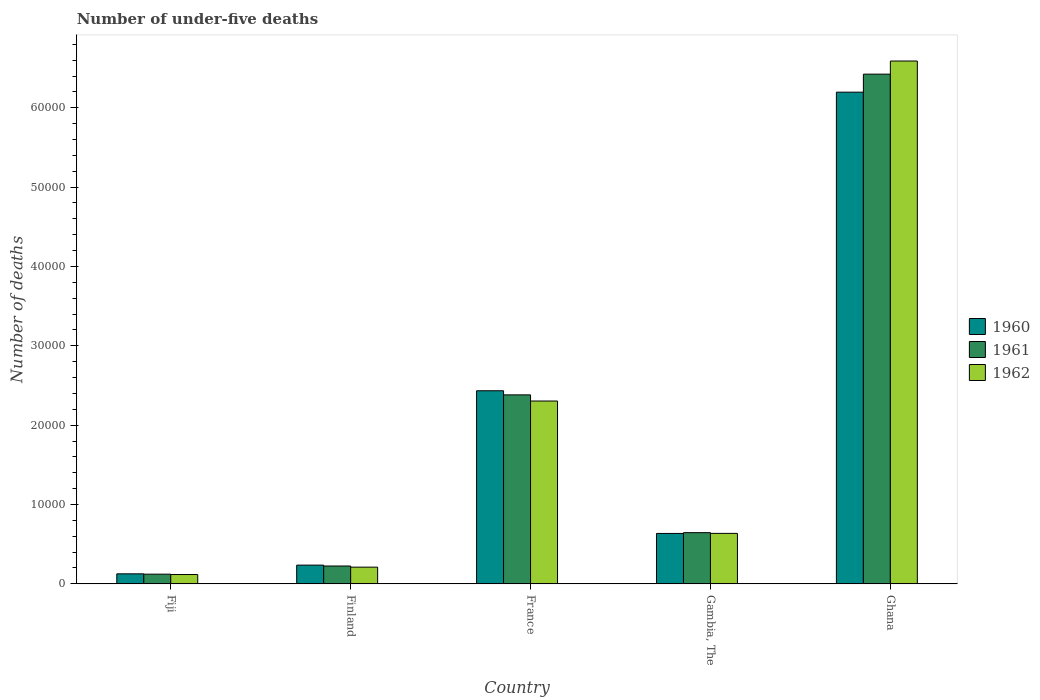How many different coloured bars are there?
Provide a short and direct response. 3. How many bars are there on the 5th tick from the right?
Offer a terse response. 3. In how many cases, is the number of bars for a given country not equal to the number of legend labels?
Offer a very short reply. 0. What is the number of under-five deaths in 1962 in Finland?
Your answer should be very brief. 2106. Across all countries, what is the maximum number of under-five deaths in 1961?
Make the answer very short. 6.42e+04. Across all countries, what is the minimum number of under-five deaths in 1962?
Give a very brief answer. 1176. In which country was the number of under-five deaths in 1961 minimum?
Make the answer very short. Fiji. What is the total number of under-five deaths in 1960 in the graph?
Provide a short and direct response. 9.63e+04. What is the difference between the number of under-five deaths in 1960 in Finland and that in Gambia, The?
Keep it short and to the point. -3990. What is the difference between the number of under-five deaths in 1960 in Gambia, The and the number of under-five deaths in 1961 in Fiji?
Your answer should be very brief. 5131. What is the average number of under-five deaths in 1960 per country?
Make the answer very short. 1.93e+04. What is the difference between the number of under-five deaths of/in 1961 and number of under-five deaths of/in 1960 in France?
Your answer should be compact. -517. In how many countries, is the number of under-five deaths in 1961 greater than 58000?
Make the answer very short. 1. What is the ratio of the number of under-five deaths in 1960 in Finland to that in Ghana?
Offer a terse response. 0.04. Is the difference between the number of under-five deaths in 1961 in Fiji and France greater than the difference between the number of under-five deaths in 1960 in Fiji and France?
Provide a succinct answer. Yes. What is the difference between the highest and the second highest number of under-five deaths in 1961?
Ensure brevity in your answer.  1.74e+04. What is the difference between the highest and the lowest number of under-five deaths in 1960?
Offer a terse response. 6.07e+04. In how many countries, is the number of under-five deaths in 1961 greater than the average number of under-five deaths in 1961 taken over all countries?
Offer a terse response. 2. Is the sum of the number of under-five deaths in 1960 in Gambia, The and Ghana greater than the maximum number of under-five deaths in 1961 across all countries?
Give a very brief answer. Yes. What does the 3rd bar from the left in Finland represents?
Give a very brief answer. 1962. What does the 1st bar from the right in Gambia, The represents?
Offer a very short reply. 1962. How many bars are there?
Give a very brief answer. 15. How many countries are there in the graph?
Give a very brief answer. 5. What is the difference between two consecutive major ticks on the Y-axis?
Ensure brevity in your answer.  10000. Does the graph contain any zero values?
Your response must be concise. No. Does the graph contain grids?
Offer a terse response. No. What is the title of the graph?
Offer a very short reply. Number of under-five deaths. Does "1988" appear as one of the legend labels in the graph?
Provide a succinct answer. No. What is the label or title of the Y-axis?
Offer a very short reply. Number of deaths. What is the Number of deaths of 1960 in Fiji?
Your answer should be very brief. 1263. What is the Number of deaths in 1961 in Fiji?
Give a very brief answer. 1222. What is the Number of deaths in 1962 in Fiji?
Provide a short and direct response. 1176. What is the Number of deaths in 1960 in Finland?
Your answer should be very brief. 2363. What is the Number of deaths in 1961 in Finland?
Keep it short and to the point. 2251. What is the Number of deaths in 1962 in Finland?
Your answer should be compact. 2106. What is the Number of deaths in 1960 in France?
Provide a short and direct response. 2.43e+04. What is the Number of deaths in 1961 in France?
Make the answer very short. 2.38e+04. What is the Number of deaths of 1962 in France?
Your answer should be very brief. 2.30e+04. What is the Number of deaths of 1960 in Gambia, The?
Ensure brevity in your answer.  6353. What is the Number of deaths in 1961 in Gambia, The?
Provide a short and direct response. 6452. What is the Number of deaths of 1962 in Gambia, The?
Your answer should be compact. 6361. What is the Number of deaths in 1960 in Ghana?
Offer a terse response. 6.20e+04. What is the Number of deaths in 1961 in Ghana?
Make the answer very short. 6.42e+04. What is the Number of deaths in 1962 in Ghana?
Your answer should be very brief. 6.59e+04. Across all countries, what is the maximum Number of deaths in 1960?
Ensure brevity in your answer.  6.20e+04. Across all countries, what is the maximum Number of deaths of 1961?
Offer a terse response. 6.42e+04. Across all countries, what is the maximum Number of deaths in 1962?
Offer a terse response. 6.59e+04. Across all countries, what is the minimum Number of deaths in 1960?
Give a very brief answer. 1263. Across all countries, what is the minimum Number of deaths of 1961?
Offer a terse response. 1222. Across all countries, what is the minimum Number of deaths in 1962?
Ensure brevity in your answer.  1176. What is the total Number of deaths in 1960 in the graph?
Offer a terse response. 9.63e+04. What is the total Number of deaths in 1961 in the graph?
Keep it short and to the point. 9.80e+04. What is the total Number of deaths in 1962 in the graph?
Offer a very short reply. 9.86e+04. What is the difference between the Number of deaths in 1960 in Fiji and that in Finland?
Offer a terse response. -1100. What is the difference between the Number of deaths in 1961 in Fiji and that in Finland?
Offer a terse response. -1029. What is the difference between the Number of deaths of 1962 in Fiji and that in Finland?
Your answer should be compact. -930. What is the difference between the Number of deaths of 1960 in Fiji and that in France?
Your answer should be compact. -2.31e+04. What is the difference between the Number of deaths of 1961 in Fiji and that in France?
Your response must be concise. -2.26e+04. What is the difference between the Number of deaths of 1962 in Fiji and that in France?
Give a very brief answer. -2.19e+04. What is the difference between the Number of deaths of 1960 in Fiji and that in Gambia, The?
Offer a terse response. -5090. What is the difference between the Number of deaths in 1961 in Fiji and that in Gambia, The?
Your answer should be compact. -5230. What is the difference between the Number of deaths of 1962 in Fiji and that in Gambia, The?
Ensure brevity in your answer.  -5185. What is the difference between the Number of deaths of 1960 in Fiji and that in Ghana?
Provide a short and direct response. -6.07e+04. What is the difference between the Number of deaths in 1961 in Fiji and that in Ghana?
Make the answer very short. -6.30e+04. What is the difference between the Number of deaths of 1962 in Fiji and that in Ghana?
Provide a succinct answer. -6.47e+04. What is the difference between the Number of deaths of 1960 in Finland and that in France?
Ensure brevity in your answer.  -2.20e+04. What is the difference between the Number of deaths in 1961 in Finland and that in France?
Ensure brevity in your answer.  -2.16e+04. What is the difference between the Number of deaths in 1962 in Finland and that in France?
Keep it short and to the point. -2.09e+04. What is the difference between the Number of deaths in 1960 in Finland and that in Gambia, The?
Offer a terse response. -3990. What is the difference between the Number of deaths of 1961 in Finland and that in Gambia, The?
Provide a short and direct response. -4201. What is the difference between the Number of deaths in 1962 in Finland and that in Gambia, The?
Ensure brevity in your answer.  -4255. What is the difference between the Number of deaths of 1960 in Finland and that in Ghana?
Ensure brevity in your answer.  -5.96e+04. What is the difference between the Number of deaths in 1961 in Finland and that in Ghana?
Offer a very short reply. -6.20e+04. What is the difference between the Number of deaths of 1962 in Finland and that in Ghana?
Your answer should be compact. -6.38e+04. What is the difference between the Number of deaths of 1960 in France and that in Gambia, The?
Offer a terse response. 1.80e+04. What is the difference between the Number of deaths of 1961 in France and that in Gambia, The?
Offer a very short reply. 1.74e+04. What is the difference between the Number of deaths of 1962 in France and that in Gambia, The?
Your answer should be compact. 1.67e+04. What is the difference between the Number of deaths of 1960 in France and that in Ghana?
Ensure brevity in your answer.  -3.76e+04. What is the difference between the Number of deaths of 1961 in France and that in Ghana?
Offer a terse response. -4.04e+04. What is the difference between the Number of deaths of 1962 in France and that in Ghana?
Provide a succinct answer. -4.28e+04. What is the difference between the Number of deaths in 1960 in Gambia, The and that in Ghana?
Ensure brevity in your answer.  -5.56e+04. What is the difference between the Number of deaths of 1961 in Gambia, The and that in Ghana?
Offer a terse response. -5.78e+04. What is the difference between the Number of deaths in 1962 in Gambia, The and that in Ghana?
Ensure brevity in your answer.  -5.95e+04. What is the difference between the Number of deaths in 1960 in Fiji and the Number of deaths in 1961 in Finland?
Provide a succinct answer. -988. What is the difference between the Number of deaths in 1960 in Fiji and the Number of deaths in 1962 in Finland?
Your response must be concise. -843. What is the difference between the Number of deaths of 1961 in Fiji and the Number of deaths of 1962 in Finland?
Give a very brief answer. -884. What is the difference between the Number of deaths of 1960 in Fiji and the Number of deaths of 1961 in France?
Provide a succinct answer. -2.26e+04. What is the difference between the Number of deaths of 1960 in Fiji and the Number of deaths of 1962 in France?
Make the answer very short. -2.18e+04. What is the difference between the Number of deaths in 1961 in Fiji and the Number of deaths in 1962 in France?
Your answer should be compact. -2.18e+04. What is the difference between the Number of deaths of 1960 in Fiji and the Number of deaths of 1961 in Gambia, The?
Offer a very short reply. -5189. What is the difference between the Number of deaths of 1960 in Fiji and the Number of deaths of 1962 in Gambia, The?
Offer a terse response. -5098. What is the difference between the Number of deaths in 1961 in Fiji and the Number of deaths in 1962 in Gambia, The?
Keep it short and to the point. -5139. What is the difference between the Number of deaths in 1960 in Fiji and the Number of deaths in 1961 in Ghana?
Offer a terse response. -6.30e+04. What is the difference between the Number of deaths of 1960 in Fiji and the Number of deaths of 1962 in Ghana?
Give a very brief answer. -6.46e+04. What is the difference between the Number of deaths of 1961 in Fiji and the Number of deaths of 1962 in Ghana?
Ensure brevity in your answer.  -6.47e+04. What is the difference between the Number of deaths in 1960 in Finland and the Number of deaths in 1961 in France?
Give a very brief answer. -2.15e+04. What is the difference between the Number of deaths of 1960 in Finland and the Number of deaths of 1962 in France?
Your response must be concise. -2.07e+04. What is the difference between the Number of deaths of 1961 in Finland and the Number of deaths of 1962 in France?
Offer a terse response. -2.08e+04. What is the difference between the Number of deaths of 1960 in Finland and the Number of deaths of 1961 in Gambia, The?
Offer a very short reply. -4089. What is the difference between the Number of deaths of 1960 in Finland and the Number of deaths of 1962 in Gambia, The?
Your response must be concise. -3998. What is the difference between the Number of deaths of 1961 in Finland and the Number of deaths of 1962 in Gambia, The?
Your answer should be very brief. -4110. What is the difference between the Number of deaths in 1960 in Finland and the Number of deaths in 1961 in Ghana?
Provide a succinct answer. -6.19e+04. What is the difference between the Number of deaths of 1960 in Finland and the Number of deaths of 1962 in Ghana?
Your answer should be compact. -6.35e+04. What is the difference between the Number of deaths of 1961 in Finland and the Number of deaths of 1962 in Ghana?
Your answer should be very brief. -6.36e+04. What is the difference between the Number of deaths of 1960 in France and the Number of deaths of 1961 in Gambia, The?
Offer a terse response. 1.79e+04. What is the difference between the Number of deaths of 1960 in France and the Number of deaths of 1962 in Gambia, The?
Make the answer very short. 1.80e+04. What is the difference between the Number of deaths in 1961 in France and the Number of deaths in 1962 in Gambia, The?
Give a very brief answer. 1.75e+04. What is the difference between the Number of deaths in 1960 in France and the Number of deaths in 1961 in Ghana?
Your answer should be very brief. -3.99e+04. What is the difference between the Number of deaths in 1960 in France and the Number of deaths in 1962 in Ghana?
Your response must be concise. -4.16e+04. What is the difference between the Number of deaths in 1961 in France and the Number of deaths in 1962 in Ghana?
Your answer should be compact. -4.21e+04. What is the difference between the Number of deaths in 1960 in Gambia, The and the Number of deaths in 1961 in Ghana?
Provide a short and direct response. -5.79e+04. What is the difference between the Number of deaths of 1960 in Gambia, The and the Number of deaths of 1962 in Ghana?
Your response must be concise. -5.95e+04. What is the difference between the Number of deaths of 1961 in Gambia, The and the Number of deaths of 1962 in Ghana?
Your response must be concise. -5.94e+04. What is the average Number of deaths in 1960 per country?
Provide a succinct answer. 1.93e+04. What is the average Number of deaths in 1961 per country?
Offer a terse response. 1.96e+04. What is the average Number of deaths in 1962 per country?
Provide a succinct answer. 1.97e+04. What is the difference between the Number of deaths in 1961 and Number of deaths in 1962 in Fiji?
Ensure brevity in your answer.  46. What is the difference between the Number of deaths of 1960 and Number of deaths of 1961 in Finland?
Offer a terse response. 112. What is the difference between the Number of deaths in 1960 and Number of deaths in 1962 in Finland?
Your answer should be very brief. 257. What is the difference between the Number of deaths of 1961 and Number of deaths of 1962 in Finland?
Your response must be concise. 145. What is the difference between the Number of deaths in 1960 and Number of deaths in 1961 in France?
Provide a succinct answer. 517. What is the difference between the Number of deaths in 1960 and Number of deaths in 1962 in France?
Your answer should be compact. 1292. What is the difference between the Number of deaths of 1961 and Number of deaths of 1962 in France?
Your answer should be very brief. 775. What is the difference between the Number of deaths of 1960 and Number of deaths of 1961 in Gambia, The?
Offer a very short reply. -99. What is the difference between the Number of deaths in 1960 and Number of deaths in 1962 in Gambia, The?
Your answer should be compact. -8. What is the difference between the Number of deaths of 1961 and Number of deaths of 1962 in Gambia, The?
Your response must be concise. 91. What is the difference between the Number of deaths in 1960 and Number of deaths in 1961 in Ghana?
Your answer should be very brief. -2271. What is the difference between the Number of deaths in 1960 and Number of deaths in 1962 in Ghana?
Give a very brief answer. -3925. What is the difference between the Number of deaths of 1961 and Number of deaths of 1962 in Ghana?
Give a very brief answer. -1654. What is the ratio of the Number of deaths in 1960 in Fiji to that in Finland?
Your answer should be compact. 0.53. What is the ratio of the Number of deaths of 1961 in Fiji to that in Finland?
Your answer should be compact. 0.54. What is the ratio of the Number of deaths of 1962 in Fiji to that in Finland?
Provide a short and direct response. 0.56. What is the ratio of the Number of deaths of 1960 in Fiji to that in France?
Provide a succinct answer. 0.05. What is the ratio of the Number of deaths in 1961 in Fiji to that in France?
Offer a very short reply. 0.05. What is the ratio of the Number of deaths of 1962 in Fiji to that in France?
Your response must be concise. 0.05. What is the ratio of the Number of deaths of 1960 in Fiji to that in Gambia, The?
Your answer should be very brief. 0.2. What is the ratio of the Number of deaths in 1961 in Fiji to that in Gambia, The?
Provide a short and direct response. 0.19. What is the ratio of the Number of deaths of 1962 in Fiji to that in Gambia, The?
Give a very brief answer. 0.18. What is the ratio of the Number of deaths in 1960 in Fiji to that in Ghana?
Keep it short and to the point. 0.02. What is the ratio of the Number of deaths in 1961 in Fiji to that in Ghana?
Provide a succinct answer. 0.02. What is the ratio of the Number of deaths in 1962 in Fiji to that in Ghana?
Make the answer very short. 0.02. What is the ratio of the Number of deaths in 1960 in Finland to that in France?
Offer a terse response. 0.1. What is the ratio of the Number of deaths in 1961 in Finland to that in France?
Make the answer very short. 0.09. What is the ratio of the Number of deaths of 1962 in Finland to that in France?
Provide a short and direct response. 0.09. What is the ratio of the Number of deaths in 1960 in Finland to that in Gambia, The?
Ensure brevity in your answer.  0.37. What is the ratio of the Number of deaths in 1961 in Finland to that in Gambia, The?
Offer a very short reply. 0.35. What is the ratio of the Number of deaths in 1962 in Finland to that in Gambia, The?
Your answer should be very brief. 0.33. What is the ratio of the Number of deaths in 1960 in Finland to that in Ghana?
Your answer should be very brief. 0.04. What is the ratio of the Number of deaths of 1961 in Finland to that in Ghana?
Your response must be concise. 0.04. What is the ratio of the Number of deaths of 1962 in Finland to that in Ghana?
Keep it short and to the point. 0.03. What is the ratio of the Number of deaths in 1960 in France to that in Gambia, The?
Ensure brevity in your answer.  3.83. What is the ratio of the Number of deaths in 1961 in France to that in Gambia, The?
Offer a terse response. 3.69. What is the ratio of the Number of deaths in 1962 in France to that in Gambia, The?
Your answer should be very brief. 3.62. What is the ratio of the Number of deaths of 1960 in France to that in Ghana?
Provide a succinct answer. 0.39. What is the ratio of the Number of deaths in 1961 in France to that in Ghana?
Make the answer very short. 0.37. What is the ratio of the Number of deaths of 1962 in France to that in Ghana?
Your answer should be compact. 0.35. What is the ratio of the Number of deaths in 1960 in Gambia, The to that in Ghana?
Your answer should be very brief. 0.1. What is the ratio of the Number of deaths of 1961 in Gambia, The to that in Ghana?
Keep it short and to the point. 0.1. What is the ratio of the Number of deaths of 1962 in Gambia, The to that in Ghana?
Make the answer very short. 0.1. What is the difference between the highest and the second highest Number of deaths of 1960?
Provide a short and direct response. 3.76e+04. What is the difference between the highest and the second highest Number of deaths in 1961?
Offer a very short reply. 4.04e+04. What is the difference between the highest and the second highest Number of deaths of 1962?
Offer a terse response. 4.28e+04. What is the difference between the highest and the lowest Number of deaths in 1960?
Keep it short and to the point. 6.07e+04. What is the difference between the highest and the lowest Number of deaths of 1961?
Your answer should be very brief. 6.30e+04. What is the difference between the highest and the lowest Number of deaths of 1962?
Your response must be concise. 6.47e+04. 